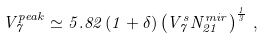Convert formula to latex. <formula><loc_0><loc_0><loc_500><loc_500>V ^ { p e a k } _ { 7 } \simeq 5 . 8 2 \, ( 1 + \delta ) \left ( V _ { 7 } ^ { s } N ^ { m i r } _ { 2 1 } \right ) ^ { \frac { 1 } { 3 } } \, ,</formula> 